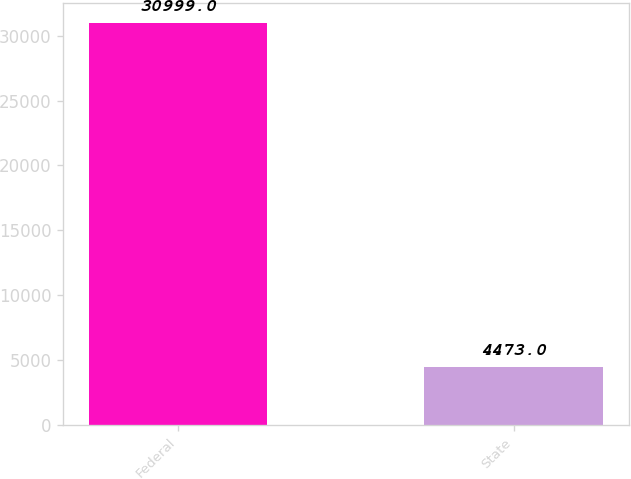Convert chart to OTSL. <chart><loc_0><loc_0><loc_500><loc_500><bar_chart><fcel>Federal<fcel>State<nl><fcel>30999<fcel>4473<nl></chart> 